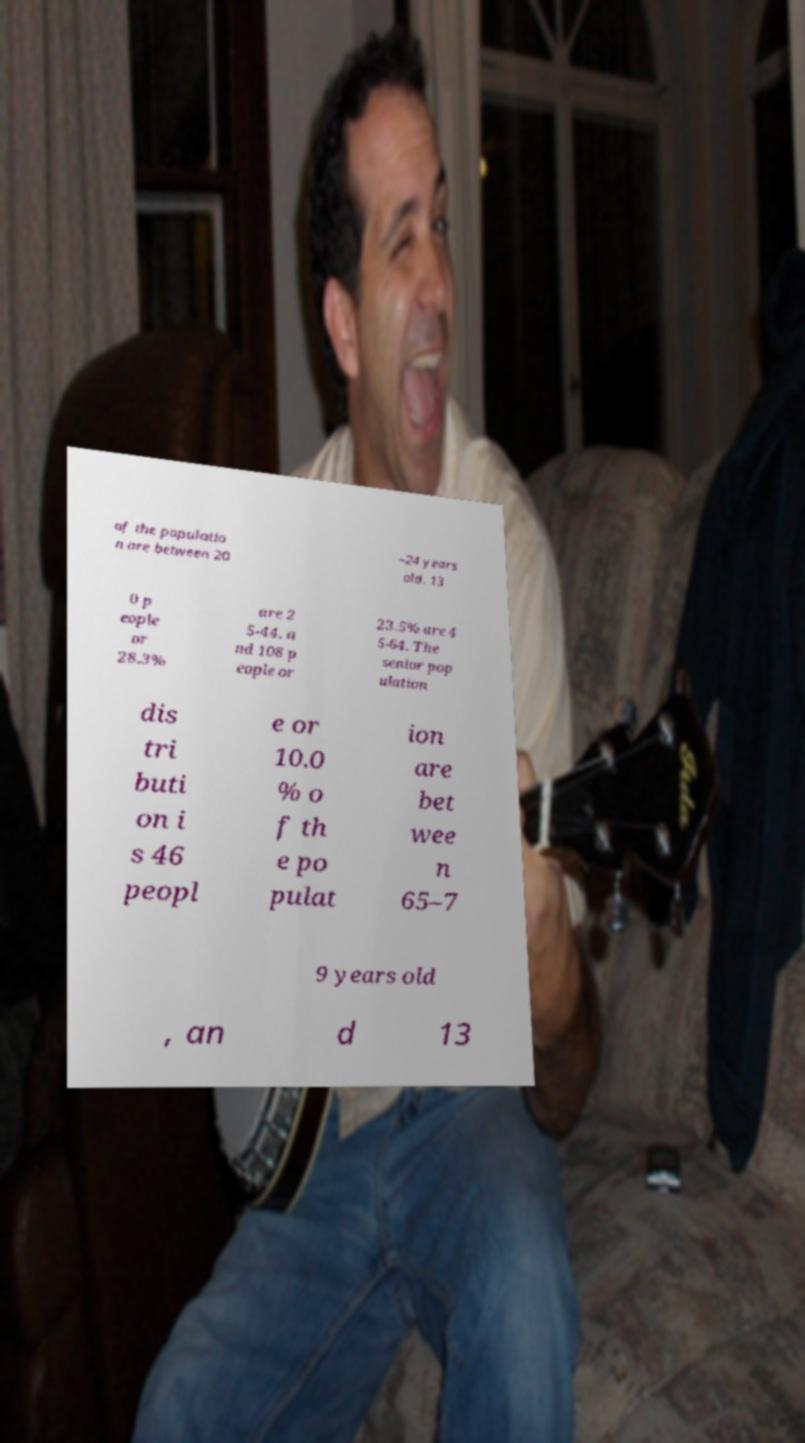For documentation purposes, I need the text within this image transcribed. Could you provide that? of the populatio n are between 20 –24 years old. 13 0 p eople or 28.3% are 2 5-44, a nd 108 p eople or 23.5% are 4 5-64. The senior pop ulation dis tri buti on i s 46 peopl e or 10.0 % o f th e po pulat ion are bet wee n 65–7 9 years old , an d 13 